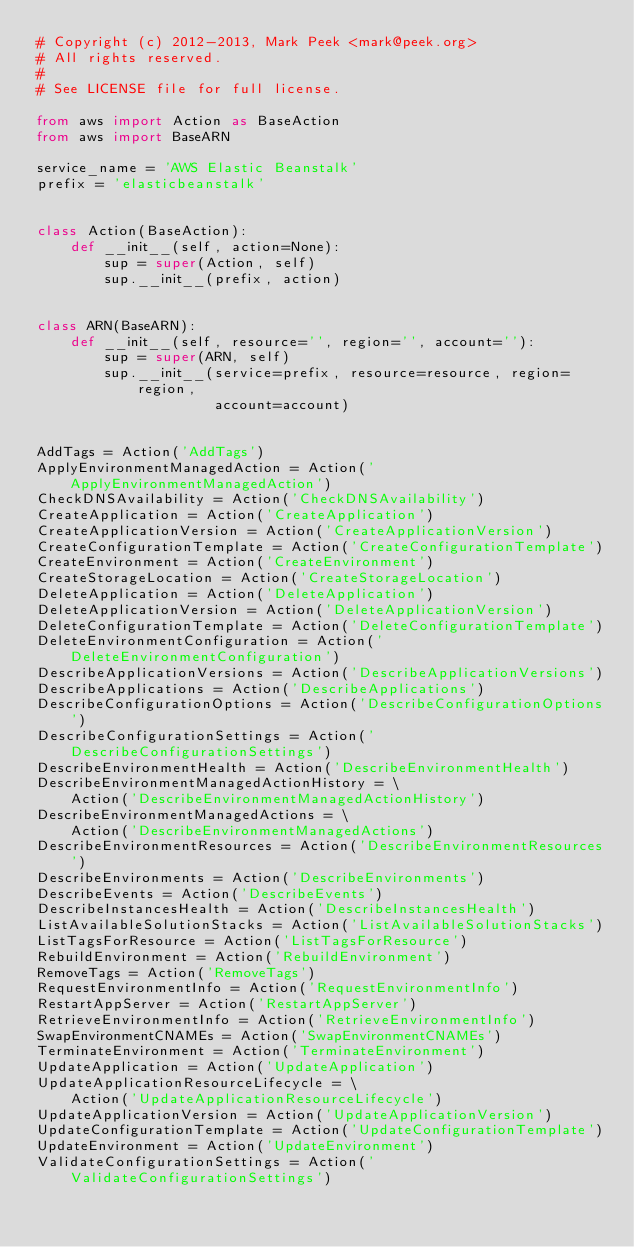<code> <loc_0><loc_0><loc_500><loc_500><_Python_># Copyright (c) 2012-2013, Mark Peek <mark@peek.org>
# All rights reserved.
#
# See LICENSE file for full license.

from aws import Action as BaseAction
from aws import BaseARN

service_name = 'AWS Elastic Beanstalk'
prefix = 'elasticbeanstalk'


class Action(BaseAction):
    def __init__(self, action=None):
        sup = super(Action, self)
        sup.__init__(prefix, action)


class ARN(BaseARN):
    def __init__(self, resource='', region='', account=''):
        sup = super(ARN, self)
        sup.__init__(service=prefix, resource=resource, region=region,
                     account=account)


AddTags = Action('AddTags')
ApplyEnvironmentManagedAction = Action('ApplyEnvironmentManagedAction')
CheckDNSAvailability = Action('CheckDNSAvailability')
CreateApplication = Action('CreateApplication')
CreateApplicationVersion = Action('CreateApplicationVersion')
CreateConfigurationTemplate = Action('CreateConfigurationTemplate')
CreateEnvironment = Action('CreateEnvironment')
CreateStorageLocation = Action('CreateStorageLocation')
DeleteApplication = Action('DeleteApplication')
DeleteApplicationVersion = Action('DeleteApplicationVersion')
DeleteConfigurationTemplate = Action('DeleteConfigurationTemplate')
DeleteEnvironmentConfiguration = Action('DeleteEnvironmentConfiguration')
DescribeApplicationVersions = Action('DescribeApplicationVersions')
DescribeApplications = Action('DescribeApplications')
DescribeConfigurationOptions = Action('DescribeConfigurationOptions')
DescribeConfigurationSettings = Action('DescribeConfigurationSettings')
DescribeEnvironmentHealth = Action('DescribeEnvironmentHealth')
DescribeEnvironmentManagedActionHistory = \
    Action('DescribeEnvironmentManagedActionHistory')
DescribeEnvironmentManagedActions = \
    Action('DescribeEnvironmentManagedActions')
DescribeEnvironmentResources = Action('DescribeEnvironmentResources')
DescribeEnvironments = Action('DescribeEnvironments')
DescribeEvents = Action('DescribeEvents')
DescribeInstancesHealth = Action('DescribeInstancesHealth')
ListAvailableSolutionStacks = Action('ListAvailableSolutionStacks')
ListTagsForResource = Action('ListTagsForResource')
RebuildEnvironment = Action('RebuildEnvironment')
RemoveTags = Action('RemoveTags')
RequestEnvironmentInfo = Action('RequestEnvironmentInfo')
RestartAppServer = Action('RestartAppServer')
RetrieveEnvironmentInfo = Action('RetrieveEnvironmentInfo')
SwapEnvironmentCNAMEs = Action('SwapEnvironmentCNAMEs')
TerminateEnvironment = Action('TerminateEnvironment')
UpdateApplication = Action('UpdateApplication')
UpdateApplicationResourceLifecycle = \
    Action('UpdateApplicationResourceLifecycle')
UpdateApplicationVersion = Action('UpdateApplicationVersion')
UpdateConfigurationTemplate = Action('UpdateConfigurationTemplate')
UpdateEnvironment = Action('UpdateEnvironment')
ValidateConfigurationSettings = Action('ValidateConfigurationSettings')
</code> 